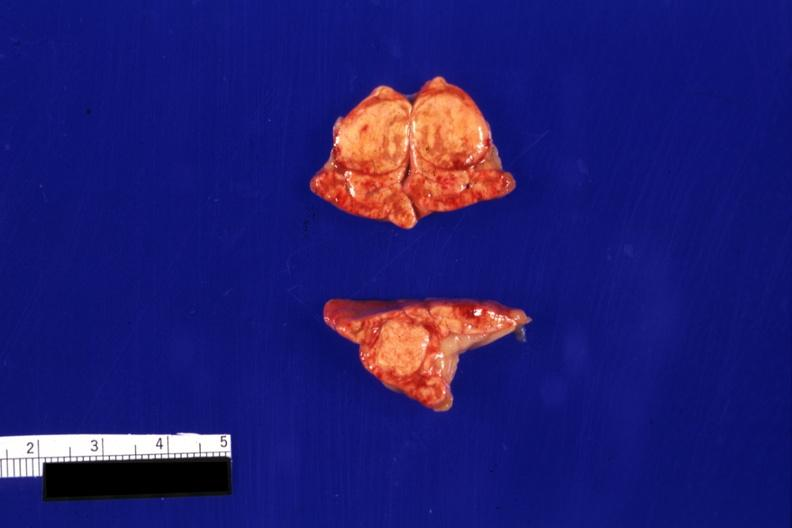s endocrine present?
Answer the question using a single word or phrase. Yes 